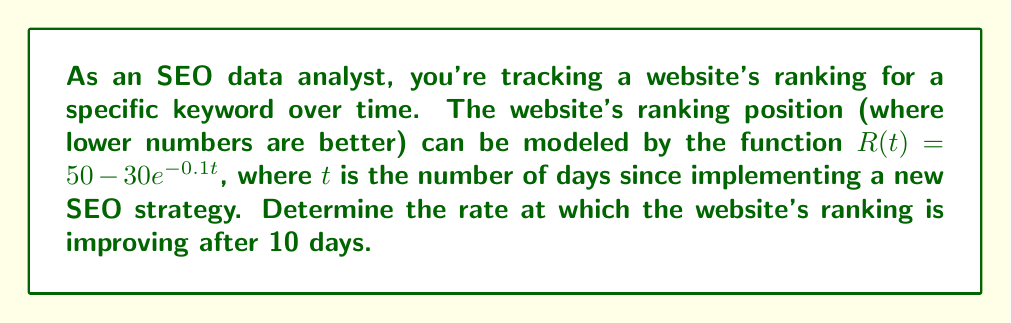Solve this math problem. To solve this problem, we need to follow these steps:

1) The rate of change in the website's ranking is given by the derivative of the ranking function $R(t)$ with respect to time $t$.

2) Let's find the derivative of $R(t)$:
   
   $R(t) = 50 - 30e^{-0.1t}$
   
   $\frac{d}{dt}R(t) = \frac{d}{dt}(50) - \frac{d}{dt}(30e^{-0.1t})$
   
   $\frac{d}{dt}R(t) = 0 - 30 \cdot (-0.1)e^{-0.1t}$
   
   $\frac{d}{dt}R(t) = 3e^{-0.1t}$

3) This derivative represents the instantaneous rate of change of the ranking at any time $t$.

4) To find the rate of change after 10 days, we need to evaluate the derivative at $t = 10$:

   $\frac{d}{dt}R(10) = 3e^{-0.1(10)}$
   
   $\frac{d}{dt}R(10) = 3e^{-1}$
   
   $\frac{d}{dt}R(10) \approx 1.10$

5) The negative sign is important here. A positive rate of change means the ranking number is increasing, which actually means the website's position is worsening. Conversely, a negative rate of change means the ranking number is decreasing, indicating improvement.

6) Therefore, we need to negate our result to represent the rate of improvement:

   Rate of improvement $= -1.10$
Answer: The website's ranking is improving at a rate of approximately 1.10 positions per day after 10 days. 